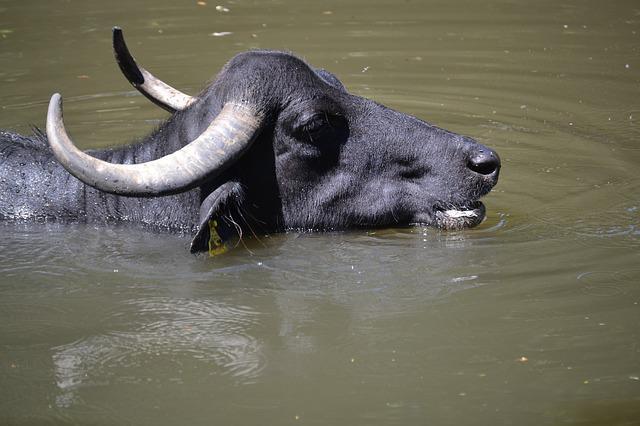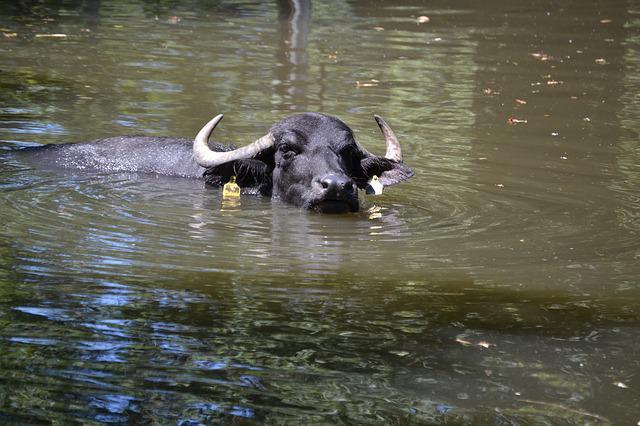The first image is the image on the left, the second image is the image on the right. Analyze the images presented: Is the assertion "An image contains a water buffalo partially under water." valid? Answer yes or no. Yes. The first image is the image on the left, the second image is the image on the right. Examine the images to the left and right. Is the description "In at least one of the images, a single water buffalo is standing in deep water." accurate? Answer yes or no. Yes. 